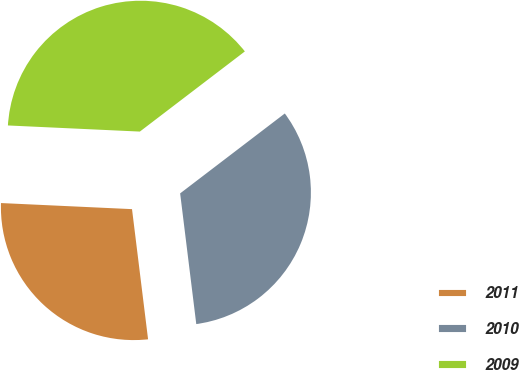<chart> <loc_0><loc_0><loc_500><loc_500><pie_chart><fcel>2011<fcel>2010<fcel>2009<nl><fcel>27.69%<fcel>33.42%<fcel>38.88%<nl></chart> 